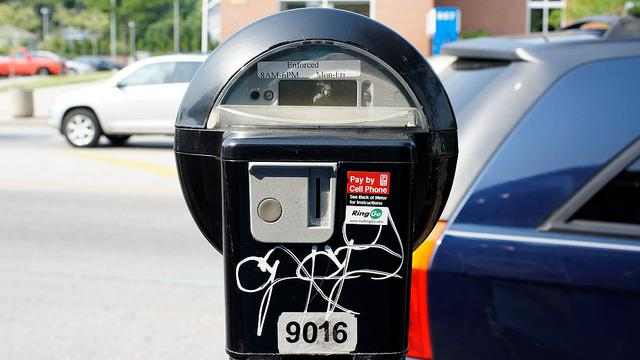What would someone need to do to use this device? insert coins 